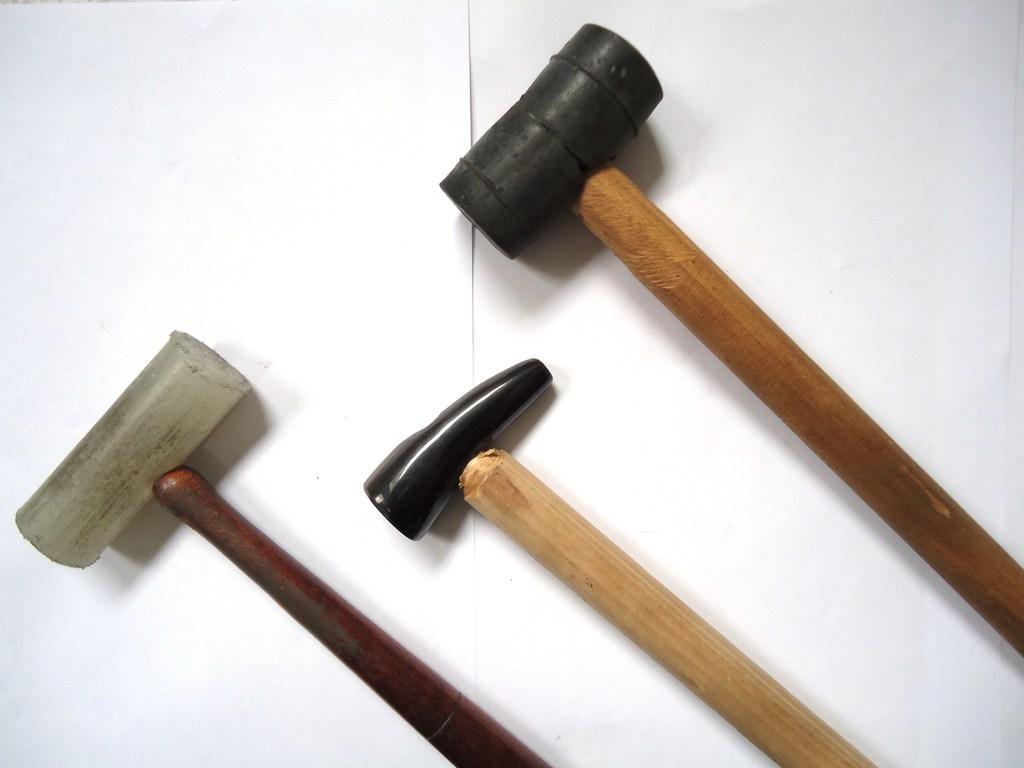How would you summarize this image in a sentence or two? There are three hammers present on the white color surface. 